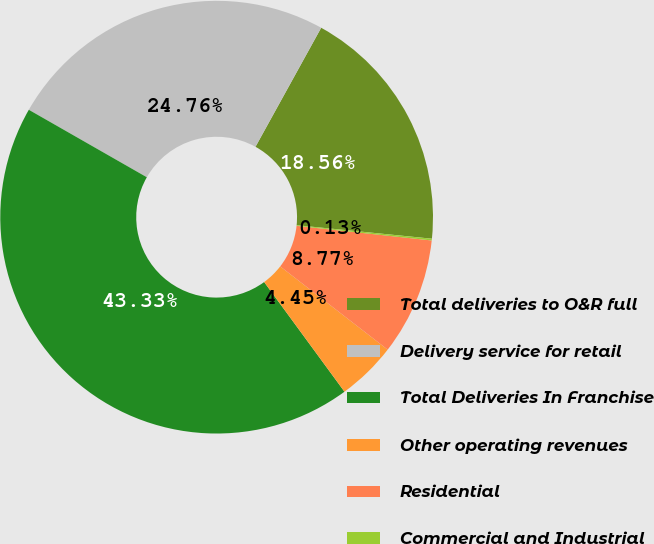<chart> <loc_0><loc_0><loc_500><loc_500><pie_chart><fcel>Total deliveries to O&R full<fcel>Delivery service for retail<fcel>Total Deliveries In Franchise<fcel>Other operating revenues<fcel>Residential<fcel>Commercial and Industrial<nl><fcel>18.56%<fcel>24.76%<fcel>43.33%<fcel>4.45%<fcel>8.77%<fcel>0.13%<nl></chart> 